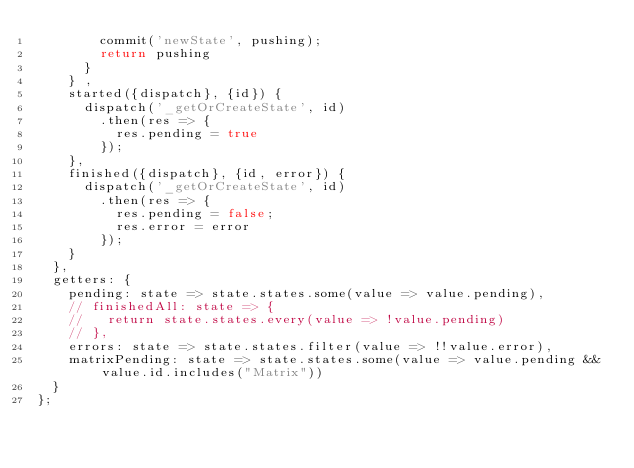<code> <loc_0><loc_0><loc_500><loc_500><_JavaScript_>        commit('newState', pushing);
        return pushing
      }
    } ,
    started({dispatch}, {id}) {
      dispatch('_getOrCreateState', id)
        .then(res => {
          res.pending = true
        });
    },
    finished({dispatch}, {id, error}) {
      dispatch('_getOrCreateState', id)
        .then(res => {
          res.pending = false;
          res.error = error
        });
    }
  },
  getters: {
    pending: state => state.states.some(value => value.pending),
    // finishedAll: state => {
    //   return state.states.every(value => !value.pending)
    // },
    errors: state => state.states.filter(value => !!value.error),
    matrixPending: state => state.states.some(value => value.pending && value.id.includes("Matrix"))
  }
};</code> 